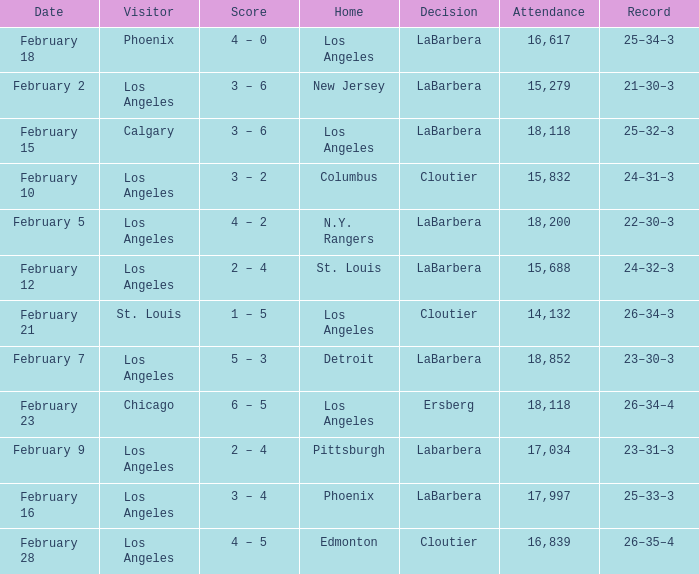What was the decision of the Kings game when Chicago was the visiting team? Ersberg. 